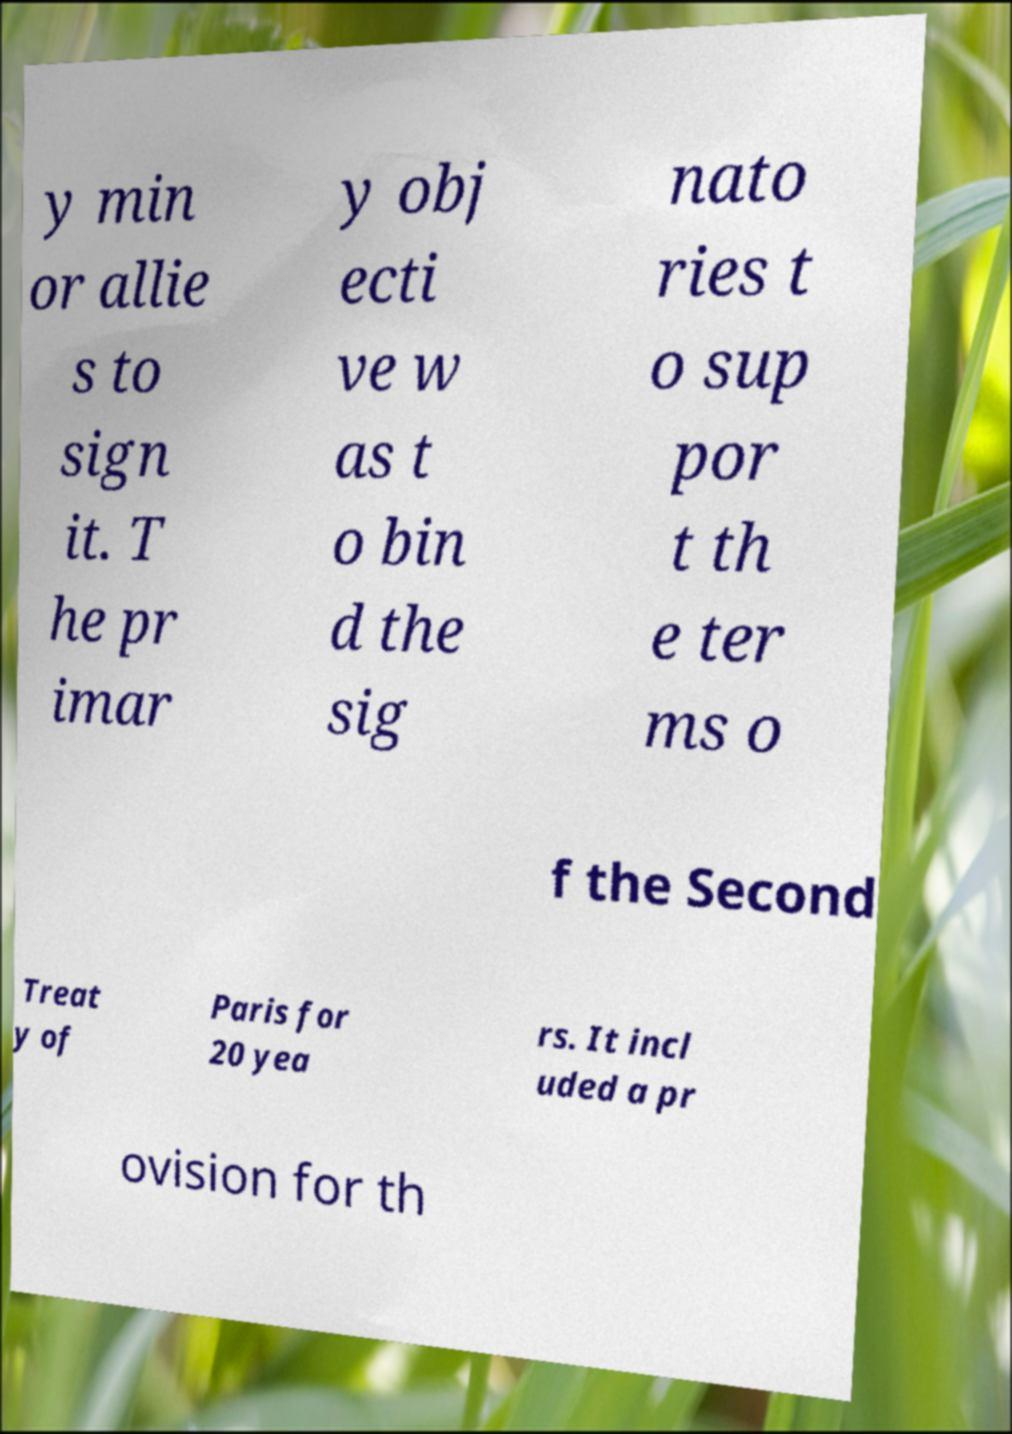Please identify and transcribe the text found in this image. y min or allie s to sign it. T he pr imar y obj ecti ve w as t o bin d the sig nato ries t o sup por t th e ter ms o f the Second Treat y of Paris for 20 yea rs. It incl uded a pr ovision for th 